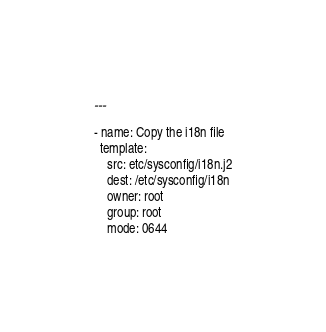Convert code to text. <code><loc_0><loc_0><loc_500><loc_500><_YAML_>---

- name: Copy the i18n file
  template:
    src: etc/sysconfig/i18n.j2
    dest: /etc/sysconfig/i18n
    owner: root
    group: root
    mode: 0644</code> 